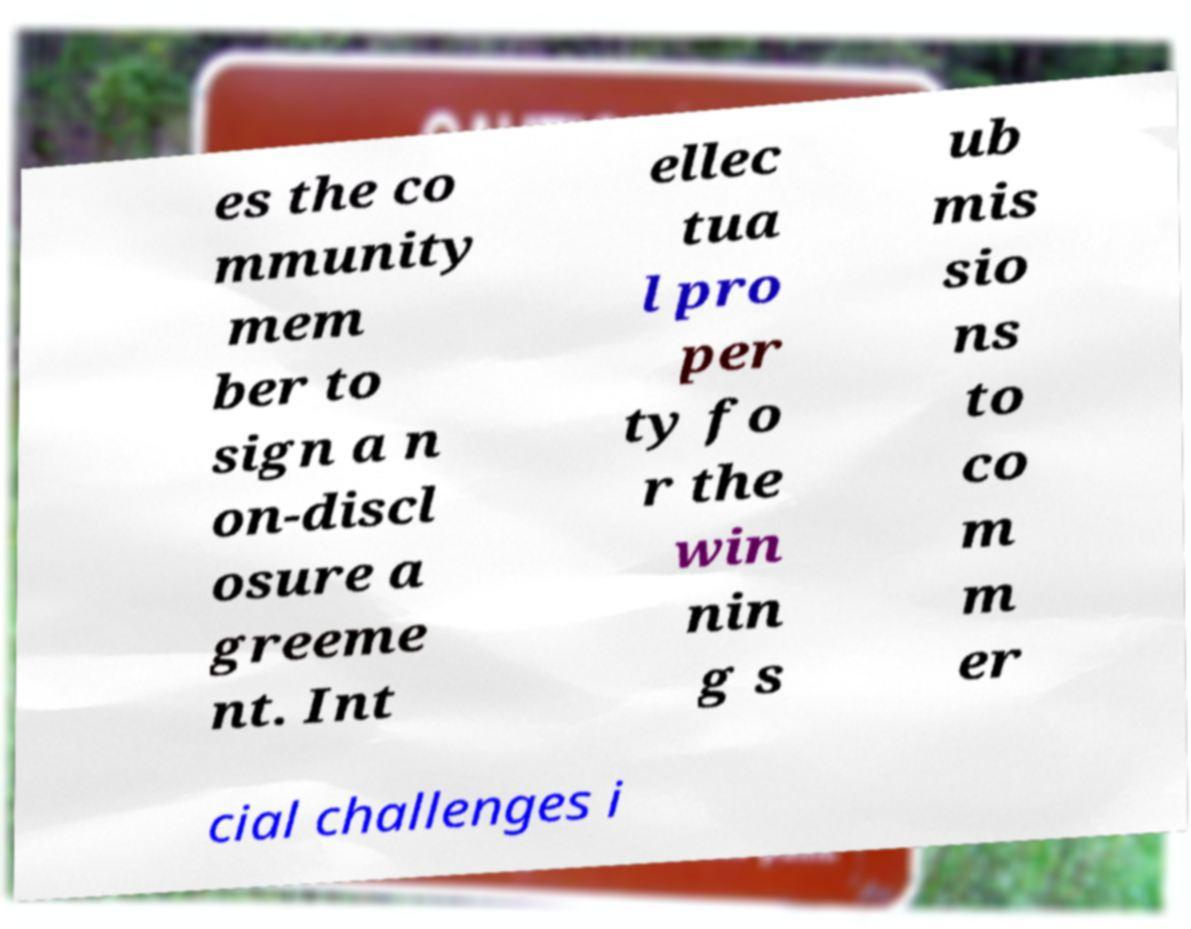What messages or text are displayed in this image? I need them in a readable, typed format. es the co mmunity mem ber to sign a n on-discl osure a greeme nt. Int ellec tua l pro per ty fo r the win nin g s ub mis sio ns to co m m er cial challenges i 